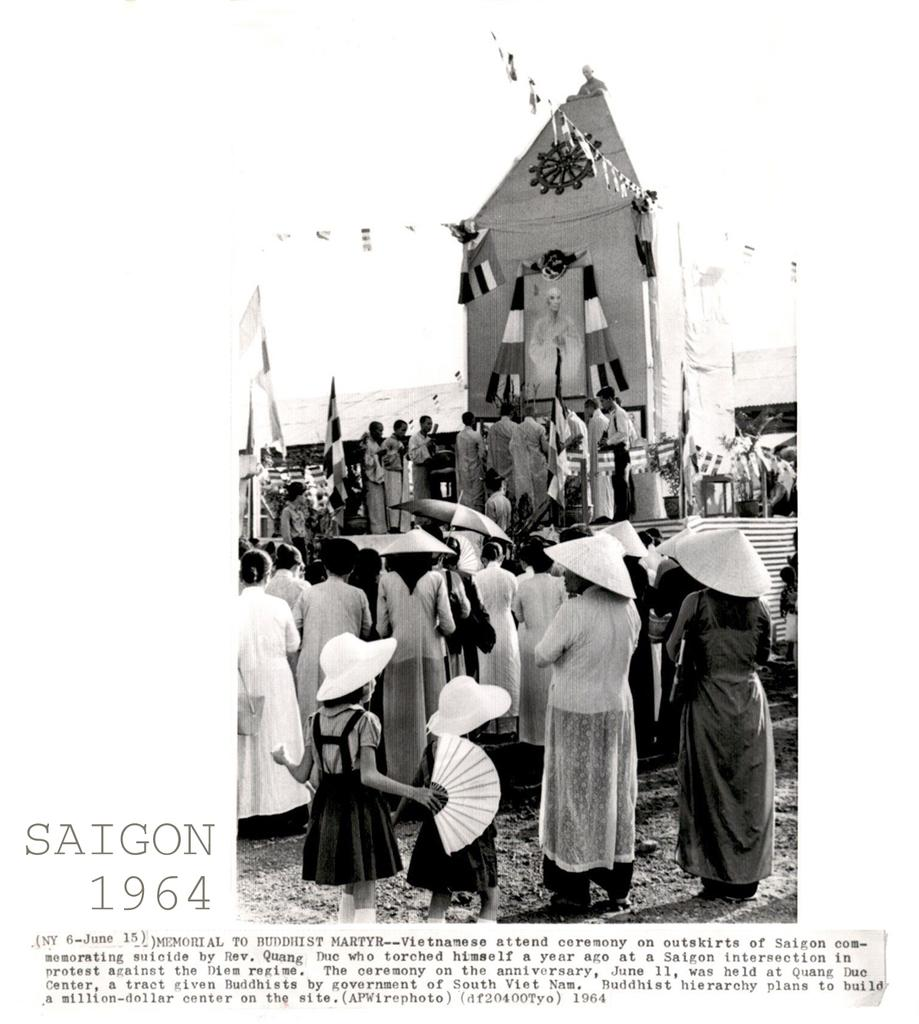What type of visual material is the image part of? The image is part of a poster. What can be seen in the image? There are persons in the image, some of whom are wearing caps. What structures are present in the image? There is a tent and a shelter in the image. What is visible in the background of the image? The sky is visible in the image. What type of pleasure can be seen being enjoyed by the persons in the image? There is no indication of pleasure being enjoyed by the persons in the image; they are simply depicted in the scene. What type of roof is present on the shelter in the image? There is no roof present on the shelter in the image; it is an open structure. 